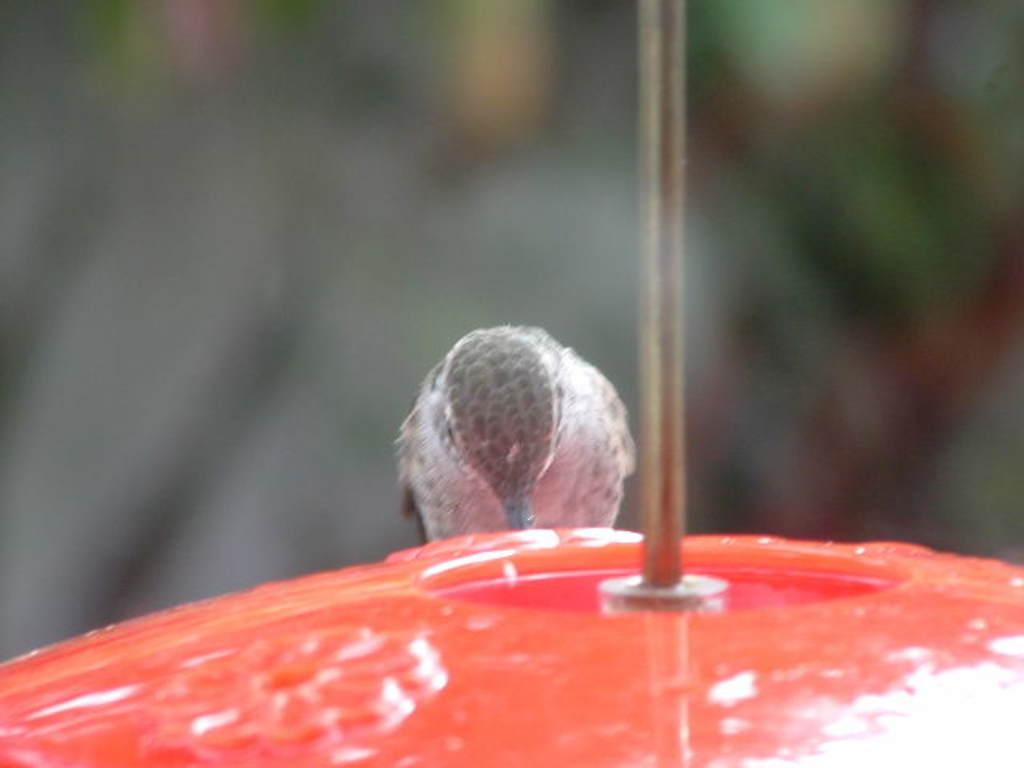Where was the image most likely taken? The image was likely clicked outside. What can be seen in the foreground of the image? There is a red color object and a rod in the foreground. What type of animal is present in the foreground? A bird appears to be standing in the foreground. How would you describe the background of the image? The background of the image is blurry. What type of lunch is the bird eating in the image? There is no lunch present in the image, and the bird does not appear to be eating anything. Is there a train visible in the background of the image? No, there is no train visible in the image. 